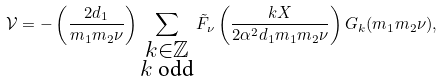Convert formula to latex. <formula><loc_0><loc_0><loc_500><loc_500>\mathcal { V } = - \left ( \frac { 2 d _ { 1 } } { m _ { 1 } m _ { 2 } \nu } \right ) \sum _ { \substack { k \in \mathbb { Z } \\ k \text { odd} } } \tilde { F } _ { \nu } \left ( \frac { k X } { 2 \alpha ^ { 2 } d _ { 1 } m _ { 1 } m _ { 2 } \nu } \right ) G _ { k } ( m _ { 1 } m _ { 2 } \nu ) ,</formula> 